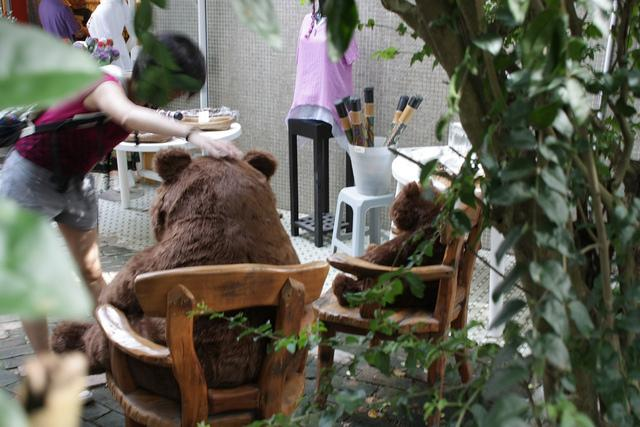How many bears are there? Please explain your reasoning. two. There is one bear in one chair and a smaller bear in the chair to the right. 